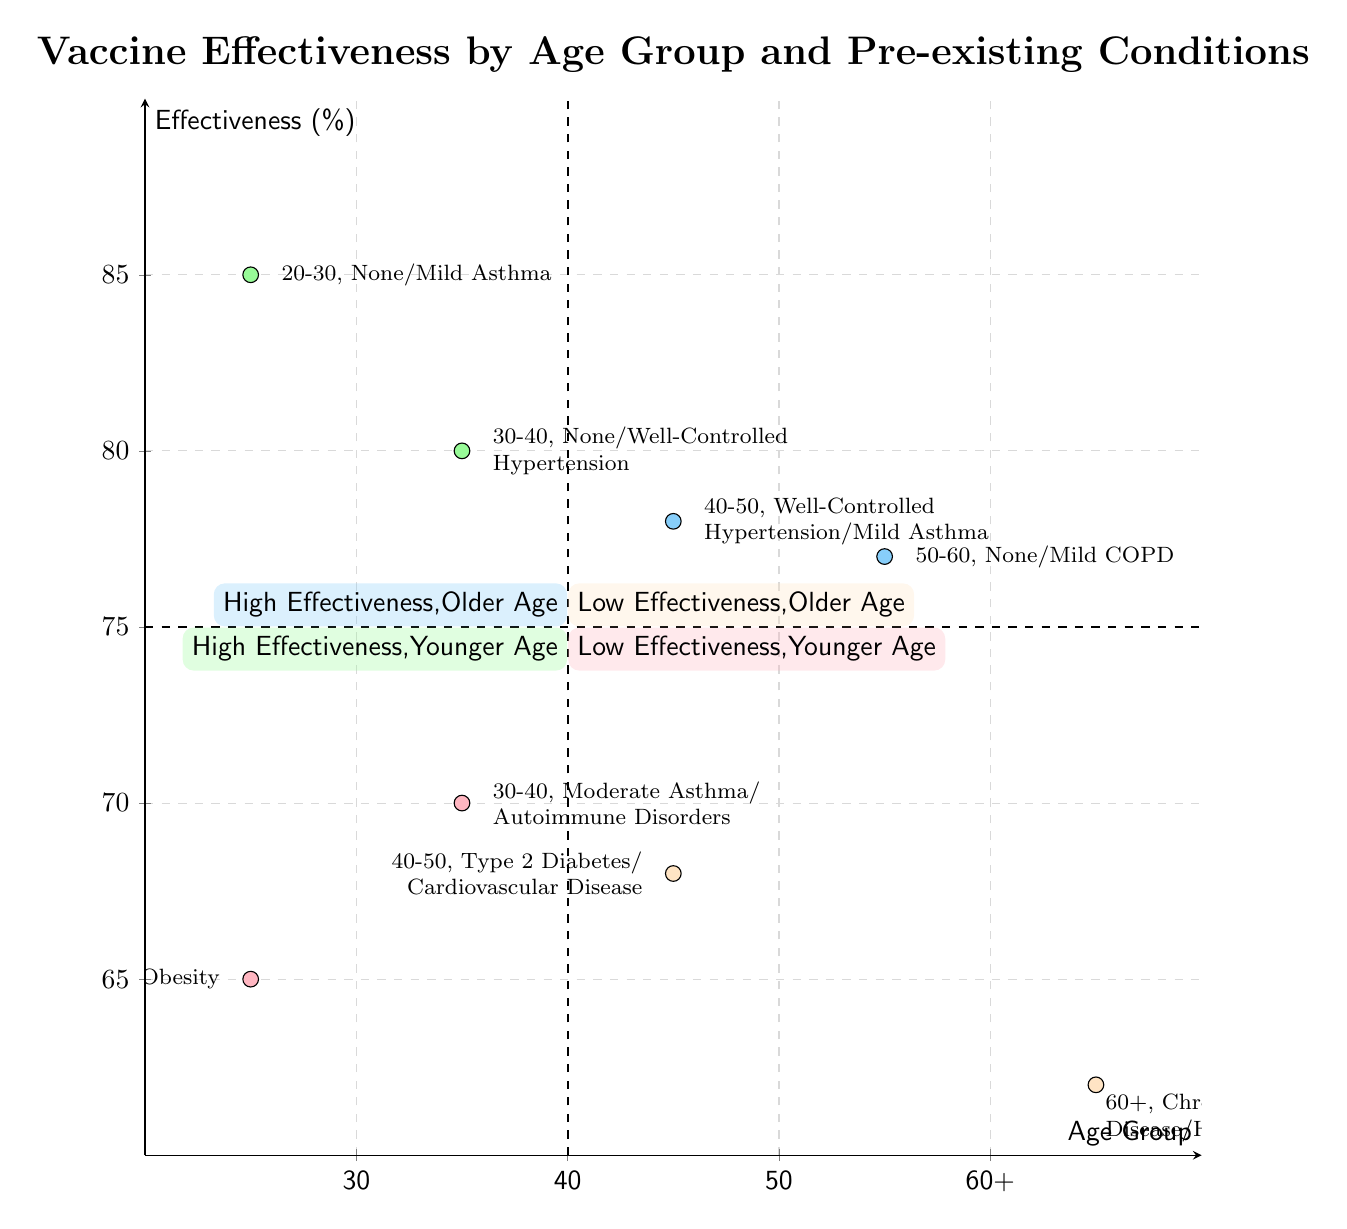What is the effectiveness percentage for the age group 20-30 with no pre-existing conditions? Referring to the quadrant chart, the effectiveness for the age group 20-30 with no pre-existing conditions is located in the high effectiveness quadrant (above 75%). The specific value marked is 85%.
Answer: 85 How many examples are there in the "Low Effectiveness, Younger Age" quadrant? The "Low Effectiveness, Younger Age" quadrant comprises two examples: one for the age group 20-30 and one for 30-40. Thus, the total is two examples.
Answer: 2 Which age group has a effectiveness percentage of 68%? In the quadrant chart, the effectiveness percentage of 68% is associated with the age group 40-50, categorized under "Low Effectiveness, Older Age".
Answer: 40-50 What pre-existing conditions are associated with the age group 50-60? From the diagram, the age group 50-60 has the effectiveness of 77% with the associated pre-existing conditions listed as "None" and "Mild COPD".
Answer: None/Mild COPD What can be inferred about the effectiveness for older individuals compared to younger ones? Comparing the quadrants, older individuals (40+) tend to demonstrate both high and low effectiveness. The data shows examples of high effectiveness (above 75%) for ages 40-50 and 50-60, while younger individuals have more variability, with some examples showing lower effectiveness. This suggests older age groups maintain some effectiveness compared to common trends in younger groups.
Answer: Older individuals maintain effectiveness 